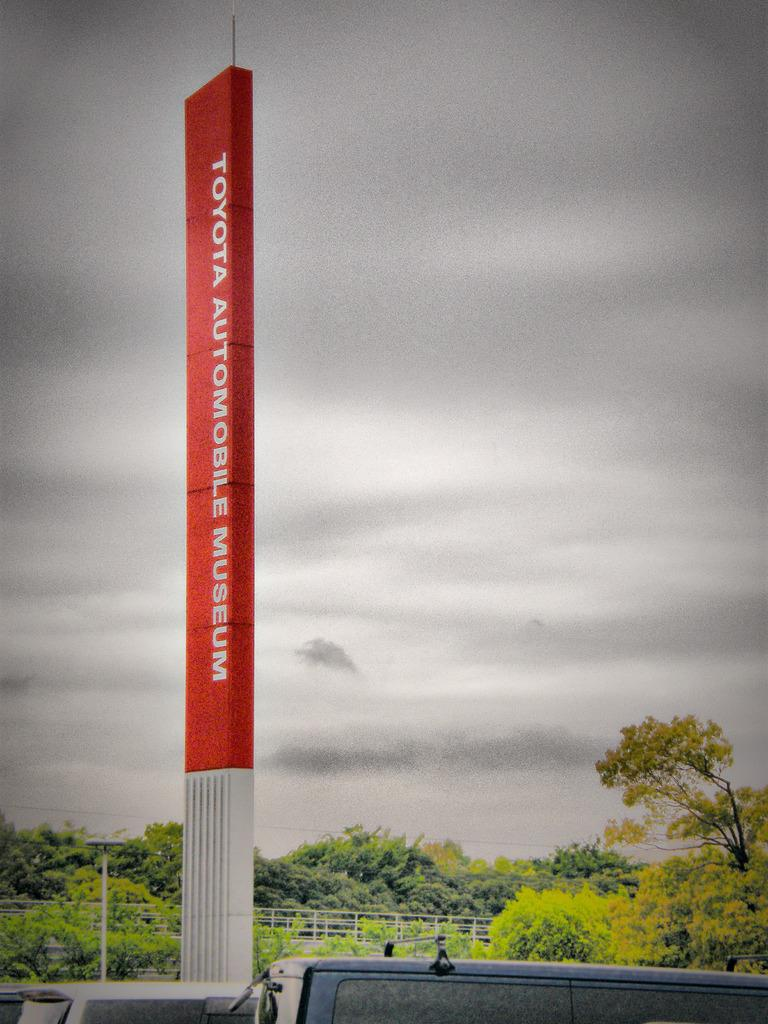<image>
Relay a brief, clear account of the picture shown. An autombile museum was created by the Toyota Corporation. 